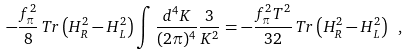Convert formula to latex. <formula><loc_0><loc_0><loc_500><loc_500>- \frac { f _ { \pi } ^ { 2 } } { 8 } \, T r \left ( H _ { R } ^ { 2 } - H _ { L } ^ { 2 } \right ) \int \frac { d ^ { 4 } K } { ( 2 \pi ) ^ { 4 } } \frac { 3 } { K ^ { 2 } } = - \frac { f _ { \pi } ^ { 2 } T ^ { 2 } } { 3 2 } \, T r \left ( H _ { R } ^ { 2 } - H _ { L } ^ { 2 } \right ) \ ,</formula> 